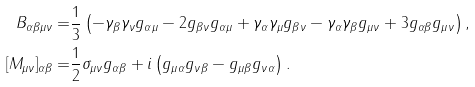<formula> <loc_0><loc_0><loc_500><loc_500>B _ { \alpha \beta \mu \nu } = & \frac { 1 } { 3 } \left ( - \gamma _ { \beta } \gamma _ { \nu } g _ { \alpha \mu } - 2 g _ { \beta \nu } g _ { \alpha \mu } + \gamma _ { \alpha } \gamma _ { \mu } g _ { \beta \nu } - \gamma _ { \alpha } \gamma _ { \beta } g _ { \mu \nu } + 3 g _ { \alpha \beta } g _ { \mu \nu } \right ) , \\ [ M _ { \mu \nu } ] _ { \alpha \beta } = & \frac { 1 } { 2 } \sigma _ { \mu \nu } g _ { \alpha \beta } + i \left ( g _ { \mu \alpha } g _ { \nu \beta } - g _ { \mu \beta } g _ { \nu \alpha } \right ) .</formula> 